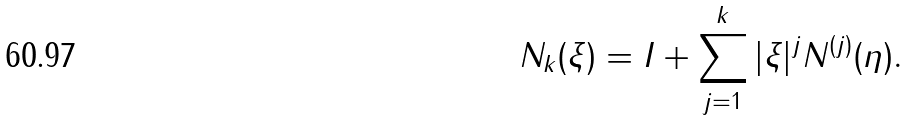Convert formula to latex. <formula><loc_0><loc_0><loc_500><loc_500>N _ { k } ( \xi ) = I + \sum _ { j = 1 } ^ { k } | \xi | ^ { j } N ^ { ( j ) } ( \eta ) .</formula> 